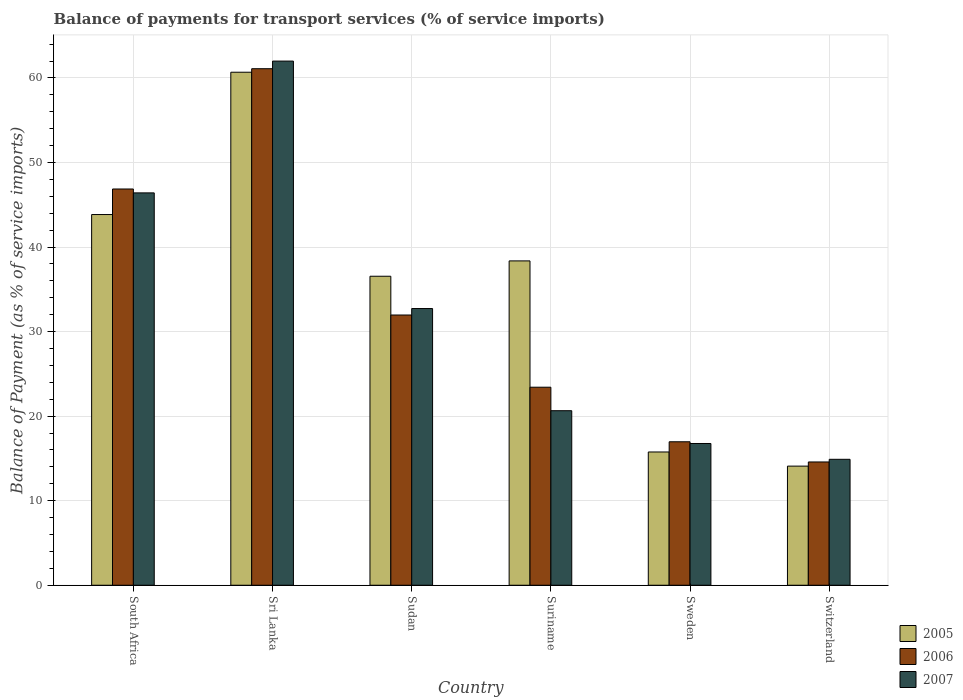How many different coloured bars are there?
Offer a very short reply. 3. How many groups of bars are there?
Offer a terse response. 6. Are the number of bars on each tick of the X-axis equal?
Give a very brief answer. Yes. What is the label of the 4th group of bars from the left?
Provide a short and direct response. Suriname. In how many cases, is the number of bars for a given country not equal to the number of legend labels?
Give a very brief answer. 0. What is the balance of payments for transport services in 2007 in Sweden?
Make the answer very short. 16.77. Across all countries, what is the maximum balance of payments for transport services in 2005?
Offer a terse response. 60.68. Across all countries, what is the minimum balance of payments for transport services in 2005?
Give a very brief answer. 14.09. In which country was the balance of payments for transport services in 2006 maximum?
Make the answer very short. Sri Lanka. In which country was the balance of payments for transport services in 2006 minimum?
Offer a very short reply. Switzerland. What is the total balance of payments for transport services in 2007 in the graph?
Ensure brevity in your answer.  193.45. What is the difference between the balance of payments for transport services in 2007 in Sudan and that in Switzerland?
Your answer should be very brief. 17.83. What is the difference between the balance of payments for transport services in 2005 in Switzerland and the balance of payments for transport services in 2006 in Suriname?
Provide a succinct answer. -9.33. What is the average balance of payments for transport services in 2005 per country?
Offer a terse response. 34.88. What is the difference between the balance of payments for transport services of/in 2007 and balance of payments for transport services of/in 2005 in South Africa?
Your response must be concise. 2.56. What is the ratio of the balance of payments for transport services in 2007 in South Africa to that in Switzerland?
Give a very brief answer. 3.12. Is the difference between the balance of payments for transport services in 2007 in South Africa and Sweden greater than the difference between the balance of payments for transport services in 2005 in South Africa and Sweden?
Your response must be concise. Yes. What is the difference between the highest and the second highest balance of payments for transport services in 2006?
Keep it short and to the point. 14.23. What is the difference between the highest and the lowest balance of payments for transport services in 2006?
Ensure brevity in your answer.  46.52. In how many countries, is the balance of payments for transport services in 2007 greater than the average balance of payments for transport services in 2007 taken over all countries?
Give a very brief answer. 3. What does the 2nd bar from the right in South Africa represents?
Your response must be concise. 2006. Is it the case that in every country, the sum of the balance of payments for transport services in 2007 and balance of payments for transport services in 2005 is greater than the balance of payments for transport services in 2006?
Provide a short and direct response. Yes. How many bars are there?
Provide a short and direct response. 18. Are all the bars in the graph horizontal?
Give a very brief answer. No. What is the difference between two consecutive major ticks on the Y-axis?
Provide a succinct answer. 10. Are the values on the major ticks of Y-axis written in scientific E-notation?
Your answer should be very brief. No. Does the graph contain grids?
Your response must be concise. Yes. How many legend labels are there?
Ensure brevity in your answer.  3. How are the legend labels stacked?
Your answer should be compact. Vertical. What is the title of the graph?
Offer a terse response. Balance of payments for transport services (% of service imports). What is the label or title of the X-axis?
Make the answer very short. Country. What is the label or title of the Y-axis?
Provide a short and direct response. Balance of Payment (as % of service imports). What is the Balance of Payment (as % of service imports) in 2005 in South Africa?
Your answer should be compact. 43.85. What is the Balance of Payment (as % of service imports) in 2006 in South Africa?
Give a very brief answer. 46.87. What is the Balance of Payment (as % of service imports) in 2007 in South Africa?
Provide a short and direct response. 46.41. What is the Balance of Payment (as % of service imports) in 2005 in Sri Lanka?
Make the answer very short. 60.68. What is the Balance of Payment (as % of service imports) of 2006 in Sri Lanka?
Ensure brevity in your answer.  61.1. What is the Balance of Payment (as % of service imports) of 2007 in Sri Lanka?
Offer a very short reply. 62. What is the Balance of Payment (as % of service imports) of 2005 in Sudan?
Keep it short and to the point. 36.55. What is the Balance of Payment (as % of service imports) in 2006 in Sudan?
Make the answer very short. 31.96. What is the Balance of Payment (as % of service imports) of 2007 in Sudan?
Your answer should be very brief. 32.73. What is the Balance of Payment (as % of service imports) of 2005 in Suriname?
Offer a very short reply. 38.37. What is the Balance of Payment (as % of service imports) in 2006 in Suriname?
Provide a short and direct response. 23.42. What is the Balance of Payment (as % of service imports) of 2007 in Suriname?
Keep it short and to the point. 20.64. What is the Balance of Payment (as % of service imports) in 2005 in Sweden?
Give a very brief answer. 15.76. What is the Balance of Payment (as % of service imports) in 2006 in Sweden?
Keep it short and to the point. 16.97. What is the Balance of Payment (as % of service imports) of 2007 in Sweden?
Offer a terse response. 16.77. What is the Balance of Payment (as % of service imports) of 2005 in Switzerland?
Your response must be concise. 14.09. What is the Balance of Payment (as % of service imports) of 2006 in Switzerland?
Keep it short and to the point. 14.58. What is the Balance of Payment (as % of service imports) of 2007 in Switzerland?
Your answer should be compact. 14.9. Across all countries, what is the maximum Balance of Payment (as % of service imports) of 2005?
Offer a very short reply. 60.68. Across all countries, what is the maximum Balance of Payment (as % of service imports) of 2006?
Keep it short and to the point. 61.1. Across all countries, what is the maximum Balance of Payment (as % of service imports) of 2007?
Give a very brief answer. 62. Across all countries, what is the minimum Balance of Payment (as % of service imports) in 2005?
Provide a short and direct response. 14.09. Across all countries, what is the minimum Balance of Payment (as % of service imports) in 2006?
Offer a very short reply. 14.58. Across all countries, what is the minimum Balance of Payment (as % of service imports) in 2007?
Your answer should be very brief. 14.9. What is the total Balance of Payment (as % of service imports) of 2005 in the graph?
Provide a succinct answer. 209.3. What is the total Balance of Payment (as % of service imports) of 2006 in the graph?
Give a very brief answer. 194.91. What is the total Balance of Payment (as % of service imports) in 2007 in the graph?
Give a very brief answer. 193.45. What is the difference between the Balance of Payment (as % of service imports) in 2005 in South Africa and that in Sri Lanka?
Your response must be concise. -16.83. What is the difference between the Balance of Payment (as % of service imports) in 2006 in South Africa and that in Sri Lanka?
Give a very brief answer. -14.23. What is the difference between the Balance of Payment (as % of service imports) in 2007 in South Africa and that in Sri Lanka?
Make the answer very short. -15.59. What is the difference between the Balance of Payment (as % of service imports) of 2005 in South Africa and that in Sudan?
Your response must be concise. 7.3. What is the difference between the Balance of Payment (as % of service imports) in 2006 in South Africa and that in Sudan?
Offer a terse response. 14.91. What is the difference between the Balance of Payment (as % of service imports) in 2007 in South Africa and that in Sudan?
Provide a succinct answer. 13.68. What is the difference between the Balance of Payment (as % of service imports) of 2005 in South Africa and that in Suriname?
Provide a short and direct response. 5.48. What is the difference between the Balance of Payment (as % of service imports) of 2006 in South Africa and that in Suriname?
Ensure brevity in your answer.  23.45. What is the difference between the Balance of Payment (as % of service imports) of 2007 in South Africa and that in Suriname?
Ensure brevity in your answer.  25.77. What is the difference between the Balance of Payment (as % of service imports) in 2005 in South Africa and that in Sweden?
Ensure brevity in your answer.  28.09. What is the difference between the Balance of Payment (as % of service imports) of 2006 in South Africa and that in Sweden?
Ensure brevity in your answer.  29.9. What is the difference between the Balance of Payment (as % of service imports) of 2007 in South Africa and that in Sweden?
Provide a short and direct response. 29.64. What is the difference between the Balance of Payment (as % of service imports) in 2005 in South Africa and that in Switzerland?
Ensure brevity in your answer.  29.76. What is the difference between the Balance of Payment (as % of service imports) in 2006 in South Africa and that in Switzerland?
Offer a terse response. 32.29. What is the difference between the Balance of Payment (as % of service imports) in 2007 in South Africa and that in Switzerland?
Keep it short and to the point. 31.51. What is the difference between the Balance of Payment (as % of service imports) in 2005 in Sri Lanka and that in Sudan?
Give a very brief answer. 24.13. What is the difference between the Balance of Payment (as % of service imports) in 2006 in Sri Lanka and that in Sudan?
Provide a succinct answer. 29.13. What is the difference between the Balance of Payment (as % of service imports) of 2007 in Sri Lanka and that in Sudan?
Keep it short and to the point. 29.27. What is the difference between the Balance of Payment (as % of service imports) of 2005 in Sri Lanka and that in Suriname?
Make the answer very short. 22.32. What is the difference between the Balance of Payment (as % of service imports) of 2006 in Sri Lanka and that in Suriname?
Your response must be concise. 37.67. What is the difference between the Balance of Payment (as % of service imports) in 2007 in Sri Lanka and that in Suriname?
Offer a very short reply. 41.36. What is the difference between the Balance of Payment (as % of service imports) of 2005 in Sri Lanka and that in Sweden?
Give a very brief answer. 44.92. What is the difference between the Balance of Payment (as % of service imports) of 2006 in Sri Lanka and that in Sweden?
Offer a terse response. 44.13. What is the difference between the Balance of Payment (as % of service imports) of 2007 in Sri Lanka and that in Sweden?
Keep it short and to the point. 45.23. What is the difference between the Balance of Payment (as % of service imports) in 2005 in Sri Lanka and that in Switzerland?
Your response must be concise. 46.59. What is the difference between the Balance of Payment (as % of service imports) in 2006 in Sri Lanka and that in Switzerland?
Your answer should be compact. 46.52. What is the difference between the Balance of Payment (as % of service imports) in 2007 in Sri Lanka and that in Switzerland?
Give a very brief answer. 47.1. What is the difference between the Balance of Payment (as % of service imports) in 2005 in Sudan and that in Suriname?
Your response must be concise. -1.82. What is the difference between the Balance of Payment (as % of service imports) of 2006 in Sudan and that in Suriname?
Provide a succinct answer. 8.54. What is the difference between the Balance of Payment (as % of service imports) of 2007 in Sudan and that in Suriname?
Offer a very short reply. 12.08. What is the difference between the Balance of Payment (as % of service imports) of 2005 in Sudan and that in Sweden?
Make the answer very short. 20.79. What is the difference between the Balance of Payment (as % of service imports) in 2006 in Sudan and that in Sweden?
Give a very brief answer. 14.99. What is the difference between the Balance of Payment (as % of service imports) of 2007 in Sudan and that in Sweden?
Make the answer very short. 15.96. What is the difference between the Balance of Payment (as % of service imports) in 2005 in Sudan and that in Switzerland?
Offer a terse response. 22.46. What is the difference between the Balance of Payment (as % of service imports) of 2006 in Sudan and that in Switzerland?
Provide a short and direct response. 17.38. What is the difference between the Balance of Payment (as % of service imports) in 2007 in Sudan and that in Switzerland?
Ensure brevity in your answer.  17.83. What is the difference between the Balance of Payment (as % of service imports) in 2005 in Suriname and that in Sweden?
Offer a very short reply. 22.6. What is the difference between the Balance of Payment (as % of service imports) of 2006 in Suriname and that in Sweden?
Give a very brief answer. 6.45. What is the difference between the Balance of Payment (as % of service imports) of 2007 in Suriname and that in Sweden?
Ensure brevity in your answer.  3.88. What is the difference between the Balance of Payment (as % of service imports) in 2005 in Suriname and that in Switzerland?
Your response must be concise. 24.28. What is the difference between the Balance of Payment (as % of service imports) of 2006 in Suriname and that in Switzerland?
Your answer should be compact. 8.84. What is the difference between the Balance of Payment (as % of service imports) of 2007 in Suriname and that in Switzerland?
Your answer should be very brief. 5.75. What is the difference between the Balance of Payment (as % of service imports) of 2005 in Sweden and that in Switzerland?
Provide a succinct answer. 1.67. What is the difference between the Balance of Payment (as % of service imports) of 2006 in Sweden and that in Switzerland?
Provide a succinct answer. 2.39. What is the difference between the Balance of Payment (as % of service imports) in 2007 in Sweden and that in Switzerland?
Offer a terse response. 1.87. What is the difference between the Balance of Payment (as % of service imports) of 2005 in South Africa and the Balance of Payment (as % of service imports) of 2006 in Sri Lanka?
Your answer should be very brief. -17.25. What is the difference between the Balance of Payment (as % of service imports) of 2005 in South Africa and the Balance of Payment (as % of service imports) of 2007 in Sri Lanka?
Your response must be concise. -18.15. What is the difference between the Balance of Payment (as % of service imports) in 2006 in South Africa and the Balance of Payment (as % of service imports) in 2007 in Sri Lanka?
Give a very brief answer. -15.13. What is the difference between the Balance of Payment (as % of service imports) in 2005 in South Africa and the Balance of Payment (as % of service imports) in 2006 in Sudan?
Ensure brevity in your answer.  11.88. What is the difference between the Balance of Payment (as % of service imports) of 2005 in South Africa and the Balance of Payment (as % of service imports) of 2007 in Sudan?
Ensure brevity in your answer.  11.12. What is the difference between the Balance of Payment (as % of service imports) of 2006 in South Africa and the Balance of Payment (as % of service imports) of 2007 in Sudan?
Keep it short and to the point. 14.14. What is the difference between the Balance of Payment (as % of service imports) of 2005 in South Africa and the Balance of Payment (as % of service imports) of 2006 in Suriname?
Your response must be concise. 20.43. What is the difference between the Balance of Payment (as % of service imports) in 2005 in South Africa and the Balance of Payment (as % of service imports) in 2007 in Suriname?
Ensure brevity in your answer.  23.2. What is the difference between the Balance of Payment (as % of service imports) of 2006 in South Africa and the Balance of Payment (as % of service imports) of 2007 in Suriname?
Offer a very short reply. 26.23. What is the difference between the Balance of Payment (as % of service imports) of 2005 in South Africa and the Balance of Payment (as % of service imports) of 2006 in Sweden?
Your answer should be compact. 26.88. What is the difference between the Balance of Payment (as % of service imports) in 2005 in South Africa and the Balance of Payment (as % of service imports) in 2007 in Sweden?
Offer a very short reply. 27.08. What is the difference between the Balance of Payment (as % of service imports) of 2006 in South Africa and the Balance of Payment (as % of service imports) of 2007 in Sweden?
Provide a short and direct response. 30.1. What is the difference between the Balance of Payment (as % of service imports) of 2005 in South Africa and the Balance of Payment (as % of service imports) of 2006 in Switzerland?
Offer a very short reply. 29.27. What is the difference between the Balance of Payment (as % of service imports) in 2005 in South Africa and the Balance of Payment (as % of service imports) in 2007 in Switzerland?
Your answer should be compact. 28.95. What is the difference between the Balance of Payment (as % of service imports) of 2006 in South Africa and the Balance of Payment (as % of service imports) of 2007 in Switzerland?
Ensure brevity in your answer.  31.97. What is the difference between the Balance of Payment (as % of service imports) in 2005 in Sri Lanka and the Balance of Payment (as % of service imports) in 2006 in Sudan?
Offer a terse response. 28.72. What is the difference between the Balance of Payment (as % of service imports) in 2005 in Sri Lanka and the Balance of Payment (as % of service imports) in 2007 in Sudan?
Make the answer very short. 27.95. What is the difference between the Balance of Payment (as % of service imports) in 2006 in Sri Lanka and the Balance of Payment (as % of service imports) in 2007 in Sudan?
Provide a short and direct response. 28.37. What is the difference between the Balance of Payment (as % of service imports) in 2005 in Sri Lanka and the Balance of Payment (as % of service imports) in 2006 in Suriname?
Give a very brief answer. 37.26. What is the difference between the Balance of Payment (as % of service imports) in 2005 in Sri Lanka and the Balance of Payment (as % of service imports) in 2007 in Suriname?
Provide a short and direct response. 40.04. What is the difference between the Balance of Payment (as % of service imports) in 2006 in Sri Lanka and the Balance of Payment (as % of service imports) in 2007 in Suriname?
Your answer should be compact. 40.45. What is the difference between the Balance of Payment (as % of service imports) in 2005 in Sri Lanka and the Balance of Payment (as % of service imports) in 2006 in Sweden?
Give a very brief answer. 43.71. What is the difference between the Balance of Payment (as % of service imports) in 2005 in Sri Lanka and the Balance of Payment (as % of service imports) in 2007 in Sweden?
Provide a short and direct response. 43.91. What is the difference between the Balance of Payment (as % of service imports) in 2006 in Sri Lanka and the Balance of Payment (as % of service imports) in 2007 in Sweden?
Keep it short and to the point. 44.33. What is the difference between the Balance of Payment (as % of service imports) in 2005 in Sri Lanka and the Balance of Payment (as % of service imports) in 2006 in Switzerland?
Your response must be concise. 46.1. What is the difference between the Balance of Payment (as % of service imports) in 2005 in Sri Lanka and the Balance of Payment (as % of service imports) in 2007 in Switzerland?
Your response must be concise. 45.79. What is the difference between the Balance of Payment (as % of service imports) in 2006 in Sri Lanka and the Balance of Payment (as % of service imports) in 2007 in Switzerland?
Provide a short and direct response. 46.2. What is the difference between the Balance of Payment (as % of service imports) in 2005 in Sudan and the Balance of Payment (as % of service imports) in 2006 in Suriname?
Make the answer very short. 13.13. What is the difference between the Balance of Payment (as % of service imports) in 2005 in Sudan and the Balance of Payment (as % of service imports) in 2007 in Suriname?
Offer a very short reply. 15.91. What is the difference between the Balance of Payment (as % of service imports) in 2006 in Sudan and the Balance of Payment (as % of service imports) in 2007 in Suriname?
Keep it short and to the point. 11.32. What is the difference between the Balance of Payment (as % of service imports) in 2005 in Sudan and the Balance of Payment (as % of service imports) in 2006 in Sweden?
Keep it short and to the point. 19.58. What is the difference between the Balance of Payment (as % of service imports) of 2005 in Sudan and the Balance of Payment (as % of service imports) of 2007 in Sweden?
Give a very brief answer. 19.78. What is the difference between the Balance of Payment (as % of service imports) in 2006 in Sudan and the Balance of Payment (as % of service imports) in 2007 in Sweden?
Provide a short and direct response. 15.2. What is the difference between the Balance of Payment (as % of service imports) of 2005 in Sudan and the Balance of Payment (as % of service imports) of 2006 in Switzerland?
Offer a very short reply. 21.97. What is the difference between the Balance of Payment (as % of service imports) of 2005 in Sudan and the Balance of Payment (as % of service imports) of 2007 in Switzerland?
Provide a short and direct response. 21.65. What is the difference between the Balance of Payment (as % of service imports) in 2006 in Sudan and the Balance of Payment (as % of service imports) in 2007 in Switzerland?
Ensure brevity in your answer.  17.07. What is the difference between the Balance of Payment (as % of service imports) of 2005 in Suriname and the Balance of Payment (as % of service imports) of 2006 in Sweden?
Ensure brevity in your answer.  21.4. What is the difference between the Balance of Payment (as % of service imports) of 2005 in Suriname and the Balance of Payment (as % of service imports) of 2007 in Sweden?
Your answer should be compact. 21.6. What is the difference between the Balance of Payment (as % of service imports) in 2006 in Suriname and the Balance of Payment (as % of service imports) in 2007 in Sweden?
Offer a very short reply. 6.66. What is the difference between the Balance of Payment (as % of service imports) of 2005 in Suriname and the Balance of Payment (as % of service imports) of 2006 in Switzerland?
Your answer should be very brief. 23.78. What is the difference between the Balance of Payment (as % of service imports) of 2005 in Suriname and the Balance of Payment (as % of service imports) of 2007 in Switzerland?
Your answer should be compact. 23.47. What is the difference between the Balance of Payment (as % of service imports) of 2006 in Suriname and the Balance of Payment (as % of service imports) of 2007 in Switzerland?
Offer a terse response. 8.53. What is the difference between the Balance of Payment (as % of service imports) in 2005 in Sweden and the Balance of Payment (as % of service imports) in 2006 in Switzerland?
Ensure brevity in your answer.  1.18. What is the difference between the Balance of Payment (as % of service imports) in 2005 in Sweden and the Balance of Payment (as % of service imports) in 2007 in Switzerland?
Provide a succinct answer. 0.87. What is the difference between the Balance of Payment (as % of service imports) of 2006 in Sweden and the Balance of Payment (as % of service imports) of 2007 in Switzerland?
Offer a terse response. 2.07. What is the average Balance of Payment (as % of service imports) in 2005 per country?
Your answer should be very brief. 34.88. What is the average Balance of Payment (as % of service imports) in 2006 per country?
Offer a terse response. 32.48. What is the average Balance of Payment (as % of service imports) of 2007 per country?
Ensure brevity in your answer.  32.24. What is the difference between the Balance of Payment (as % of service imports) in 2005 and Balance of Payment (as % of service imports) in 2006 in South Africa?
Provide a succinct answer. -3.02. What is the difference between the Balance of Payment (as % of service imports) in 2005 and Balance of Payment (as % of service imports) in 2007 in South Africa?
Your answer should be very brief. -2.56. What is the difference between the Balance of Payment (as % of service imports) in 2006 and Balance of Payment (as % of service imports) in 2007 in South Africa?
Provide a short and direct response. 0.46. What is the difference between the Balance of Payment (as % of service imports) of 2005 and Balance of Payment (as % of service imports) of 2006 in Sri Lanka?
Keep it short and to the point. -0.42. What is the difference between the Balance of Payment (as % of service imports) in 2005 and Balance of Payment (as % of service imports) in 2007 in Sri Lanka?
Offer a very short reply. -1.32. What is the difference between the Balance of Payment (as % of service imports) of 2006 and Balance of Payment (as % of service imports) of 2007 in Sri Lanka?
Make the answer very short. -0.9. What is the difference between the Balance of Payment (as % of service imports) of 2005 and Balance of Payment (as % of service imports) of 2006 in Sudan?
Your answer should be compact. 4.59. What is the difference between the Balance of Payment (as % of service imports) of 2005 and Balance of Payment (as % of service imports) of 2007 in Sudan?
Give a very brief answer. 3.82. What is the difference between the Balance of Payment (as % of service imports) in 2006 and Balance of Payment (as % of service imports) in 2007 in Sudan?
Offer a terse response. -0.76. What is the difference between the Balance of Payment (as % of service imports) in 2005 and Balance of Payment (as % of service imports) in 2006 in Suriname?
Ensure brevity in your answer.  14.94. What is the difference between the Balance of Payment (as % of service imports) of 2005 and Balance of Payment (as % of service imports) of 2007 in Suriname?
Offer a very short reply. 17.72. What is the difference between the Balance of Payment (as % of service imports) in 2006 and Balance of Payment (as % of service imports) in 2007 in Suriname?
Offer a very short reply. 2.78. What is the difference between the Balance of Payment (as % of service imports) of 2005 and Balance of Payment (as % of service imports) of 2006 in Sweden?
Ensure brevity in your answer.  -1.21. What is the difference between the Balance of Payment (as % of service imports) in 2005 and Balance of Payment (as % of service imports) in 2007 in Sweden?
Your answer should be compact. -1. What is the difference between the Balance of Payment (as % of service imports) of 2006 and Balance of Payment (as % of service imports) of 2007 in Sweden?
Keep it short and to the point. 0.2. What is the difference between the Balance of Payment (as % of service imports) of 2005 and Balance of Payment (as % of service imports) of 2006 in Switzerland?
Your answer should be very brief. -0.49. What is the difference between the Balance of Payment (as % of service imports) of 2005 and Balance of Payment (as % of service imports) of 2007 in Switzerland?
Offer a terse response. -0.81. What is the difference between the Balance of Payment (as % of service imports) of 2006 and Balance of Payment (as % of service imports) of 2007 in Switzerland?
Your answer should be very brief. -0.32. What is the ratio of the Balance of Payment (as % of service imports) in 2005 in South Africa to that in Sri Lanka?
Give a very brief answer. 0.72. What is the ratio of the Balance of Payment (as % of service imports) of 2006 in South Africa to that in Sri Lanka?
Your response must be concise. 0.77. What is the ratio of the Balance of Payment (as % of service imports) of 2007 in South Africa to that in Sri Lanka?
Keep it short and to the point. 0.75. What is the ratio of the Balance of Payment (as % of service imports) in 2005 in South Africa to that in Sudan?
Your answer should be very brief. 1.2. What is the ratio of the Balance of Payment (as % of service imports) in 2006 in South Africa to that in Sudan?
Keep it short and to the point. 1.47. What is the ratio of the Balance of Payment (as % of service imports) of 2007 in South Africa to that in Sudan?
Offer a very short reply. 1.42. What is the ratio of the Balance of Payment (as % of service imports) in 2006 in South Africa to that in Suriname?
Provide a short and direct response. 2. What is the ratio of the Balance of Payment (as % of service imports) of 2007 in South Africa to that in Suriname?
Provide a short and direct response. 2.25. What is the ratio of the Balance of Payment (as % of service imports) in 2005 in South Africa to that in Sweden?
Give a very brief answer. 2.78. What is the ratio of the Balance of Payment (as % of service imports) in 2006 in South Africa to that in Sweden?
Offer a terse response. 2.76. What is the ratio of the Balance of Payment (as % of service imports) of 2007 in South Africa to that in Sweden?
Ensure brevity in your answer.  2.77. What is the ratio of the Balance of Payment (as % of service imports) of 2005 in South Africa to that in Switzerland?
Your answer should be compact. 3.11. What is the ratio of the Balance of Payment (as % of service imports) in 2006 in South Africa to that in Switzerland?
Your answer should be compact. 3.21. What is the ratio of the Balance of Payment (as % of service imports) in 2007 in South Africa to that in Switzerland?
Give a very brief answer. 3.12. What is the ratio of the Balance of Payment (as % of service imports) in 2005 in Sri Lanka to that in Sudan?
Your response must be concise. 1.66. What is the ratio of the Balance of Payment (as % of service imports) in 2006 in Sri Lanka to that in Sudan?
Offer a very short reply. 1.91. What is the ratio of the Balance of Payment (as % of service imports) in 2007 in Sri Lanka to that in Sudan?
Give a very brief answer. 1.89. What is the ratio of the Balance of Payment (as % of service imports) of 2005 in Sri Lanka to that in Suriname?
Ensure brevity in your answer.  1.58. What is the ratio of the Balance of Payment (as % of service imports) of 2006 in Sri Lanka to that in Suriname?
Provide a short and direct response. 2.61. What is the ratio of the Balance of Payment (as % of service imports) in 2007 in Sri Lanka to that in Suriname?
Your answer should be very brief. 3. What is the ratio of the Balance of Payment (as % of service imports) of 2005 in Sri Lanka to that in Sweden?
Provide a succinct answer. 3.85. What is the ratio of the Balance of Payment (as % of service imports) of 2006 in Sri Lanka to that in Sweden?
Your answer should be very brief. 3.6. What is the ratio of the Balance of Payment (as % of service imports) in 2007 in Sri Lanka to that in Sweden?
Offer a terse response. 3.7. What is the ratio of the Balance of Payment (as % of service imports) of 2005 in Sri Lanka to that in Switzerland?
Ensure brevity in your answer.  4.31. What is the ratio of the Balance of Payment (as % of service imports) of 2006 in Sri Lanka to that in Switzerland?
Make the answer very short. 4.19. What is the ratio of the Balance of Payment (as % of service imports) in 2007 in Sri Lanka to that in Switzerland?
Ensure brevity in your answer.  4.16. What is the ratio of the Balance of Payment (as % of service imports) in 2005 in Sudan to that in Suriname?
Provide a succinct answer. 0.95. What is the ratio of the Balance of Payment (as % of service imports) of 2006 in Sudan to that in Suriname?
Provide a short and direct response. 1.36. What is the ratio of the Balance of Payment (as % of service imports) of 2007 in Sudan to that in Suriname?
Make the answer very short. 1.59. What is the ratio of the Balance of Payment (as % of service imports) of 2005 in Sudan to that in Sweden?
Your answer should be very brief. 2.32. What is the ratio of the Balance of Payment (as % of service imports) of 2006 in Sudan to that in Sweden?
Offer a terse response. 1.88. What is the ratio of the Balance of Payment (as % of service imports) in 2007 in Sudan to that in Sweden?
Give a very brief answer. 1.95. What is the ratio of the Balance of Payment (as % of service imports) of 2005 in Sudan to that in Switzerland?
Your answer should be compact. 2.59. What is the ratio of the Balance of Payment (as % of service imports) of 2006 in Sudan to that in Switzerland?
Make the answer very short. 2.19. What is the ratio of the Balance of Payment (as % of service imports) in 2007 in Sudan to that in Switzerland?
Offer a very short reply. 2.2. What is the ratio of the Balance of Payment (as % of service imports) of 2005 in Suriname to that in Sweden?
Ensure brevity in your answer.  2.43. What is the ratio of the Balance of Payment (as % of service imports) in 2006 in Suriname to that in Sweden?
Offer a very short reply. 1.38. What is the ratio of the Balance of Payment (as % of service imports) of 2007 in Suriname to that in Sweden?
Your answer should be very brief. 1.23. What is the ratio of the Balance of Payment (as % of service imports) in 2005 in Suriname to that in Switzerland?
Provide a short and direct response. 2.72. What is the ratio of the Balance of Payment (as % of service imports) in 2006 in Suriname to that in Switzerland?
Ensure brevity in your answer.  1.61. What is the ratio of the Balance of Payment (as % of service imports) of 2007 in Suriname to that in Switzerland?
Provide a short and direct response. 1.39. What is the ratio of the Balance of Payment (as % of service imports) of 2005 in Sweden to that in Switzerland?
Your answer should be very brief. 1.12. What is the ratio of the Balance of Payment (as % of service imports) in 2006 in Sweden to that in Switzerland?
Offer a terse response. 1.16. What is the ratio of the Balance of Payment (as % of service imports) in 2007 in Sweden to that in Switzerland?
Your response must be concise. 1.13. What is the difference between the highest and the second highest Balance of Payment (as % of service imports) in 2005?
Your response must be concise. 16.83. What is the difference between the highest and the second highest Balance of Payment (as % of service imports) of 2006?
Make the answer very short. 14.23. What is the difference between the highest and the second highest Balance of Payment (as % of service imports) in 2007?
Provide a succinct answer. 15.59. What is the difference between the highest and the lowest Balance of Payment (as % of service imports) in 2005?
Offer a terse response. 46.59. What is the difference between the highest and the lowest Balance of Payment (as % of service imports) in 2006?
Offer a very short reply. 46.52. What is the difference between the highest and the lowest Balance of Payment (as % of service imports) of 2007?
Give a very brief answer. 47.1. 